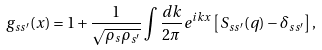<formula> <loc_0><loc_0><loc_500><loc_500>g _ { s s ^ { \prime } } ( x ) = 1 + \frac { 1 } { \sqrt { \rho _ { s } \rho _ { s ^ { \prime } } } } \int \frac { d k } { 2 \pi } e ^ { i k x } \left [ S _ { s s ^ { \prime } } ( q ) - \delta _ { s s ^ { \prime } } \right ] ,</formula> 